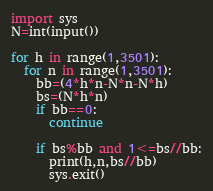<code> <loc_0><loc_0><loc_500><loc_500><_Python_>import sys
N=int(input())

for h in range(1,3501):
  for n in range(1,3501):
    bb=(4*h*n-N*n-N*h)
    bs=(N*h*n)
    if bb==0:
      continue

    if bs%bb and 1<=bs//bb:
      print(h,n,bs//bb)
      sys.exit()</code> 